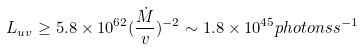Convert formula to latex. <formula><loc_0><loc_0><loc_500><loc_500>L _ { u v } \geq 5 . 8 \times 1 0 ^ { 6 2 } ( \frac { \dot { M } } { v } ) ^ { - 2 } \sim 1 . 8 \times 1 0 ^ { 4 5 } p h o t o n s s ^ { - 1 }</formula> 